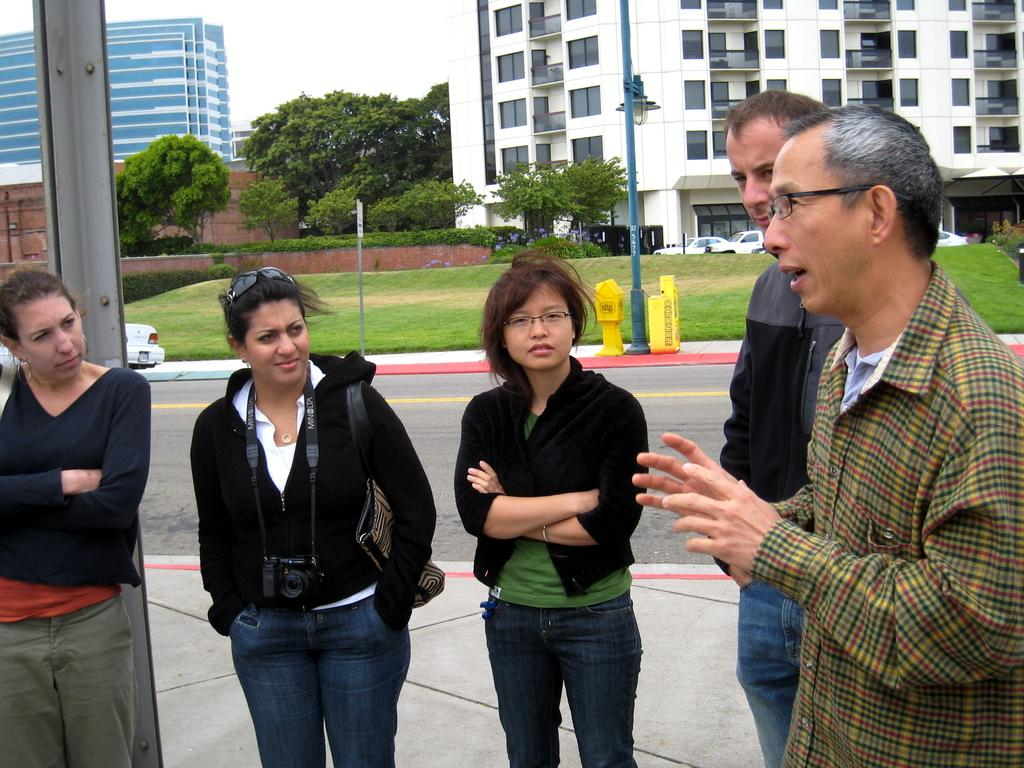How many people are in the image? There is a group of people in the image, but the exact number is not specified. What is the position of the people in the image? The people are standing on the ground. What can be seen in the background of the image? There are buildings and trees in the background of the image. What type of ink is being used by the people in the image? There is no indication in the image that the people are using ink, so it cannot be determined from the picture. 